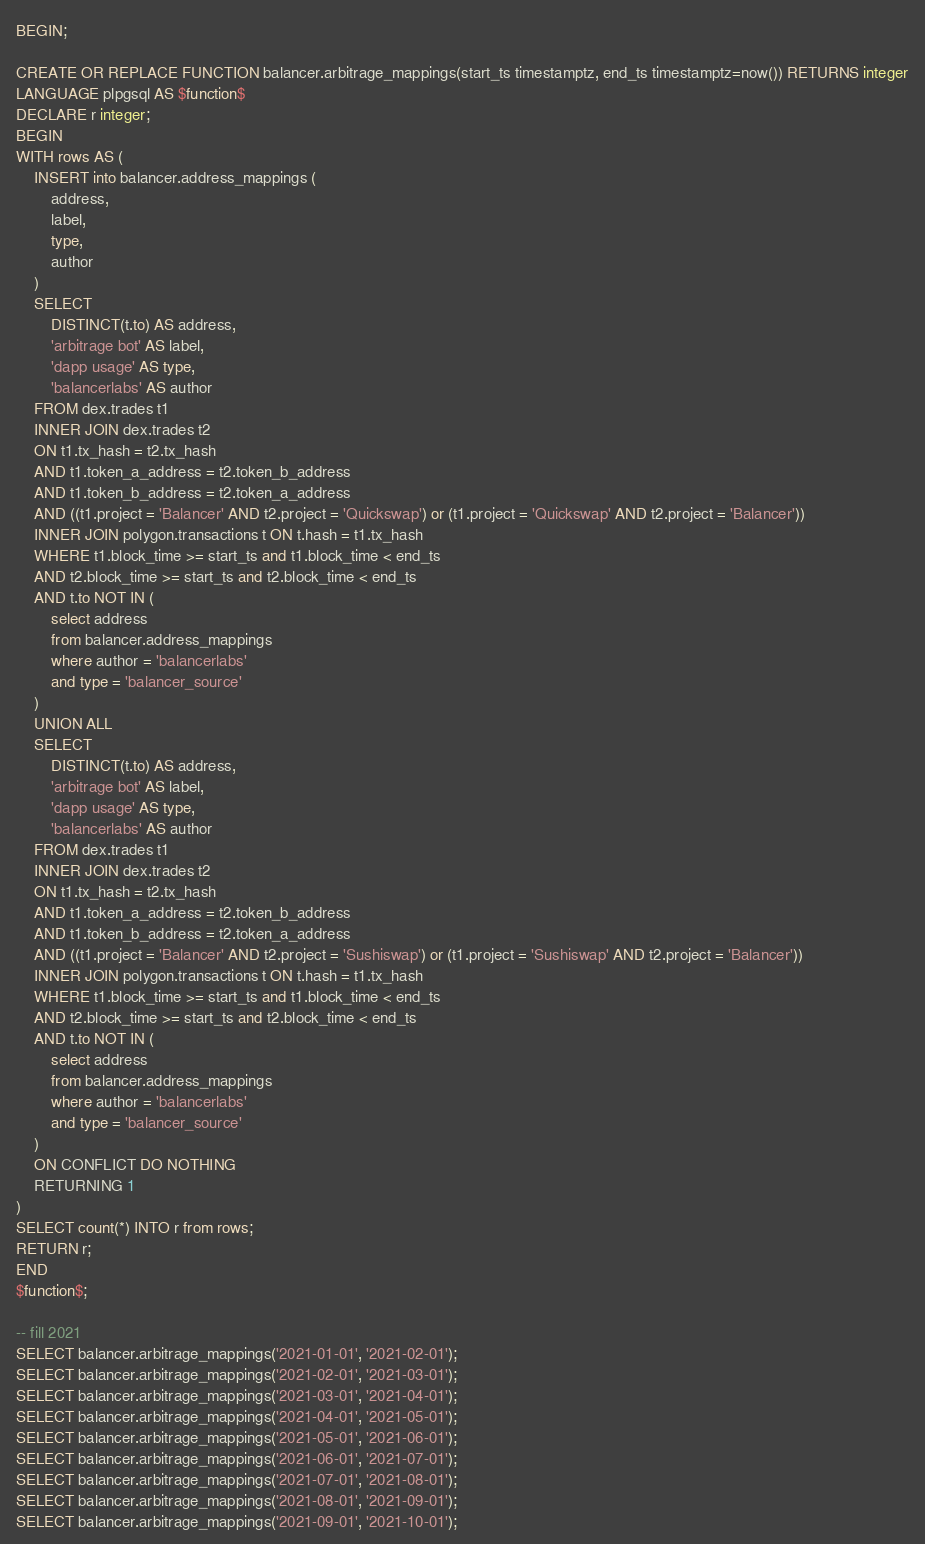<code> <loc_0><loc_0><loc_500><loc_500><_SQL_>BEGIN;

CREATE OR REPLACE FUNCTION balancer.arbitrage_mappings(start_ts timestamptz, end_ts timestamptz=now()) RETURNS integer
LANGUAGE plpgsql AS $function$
DECLARE r integer;
BEGIN
WITH rows AS (
    INSERT into balancer.address_mappings (
        address,
        label,
        type,
        author
    )
    SELECT
        DISTINCT(t.to) AS address,
        'arbitrage bot' AS label,
        'dapp usage' AS type,
        'balancerlabs' AS author
    FROM dex.trades t1
    INNER JOIN dex.trades t2
    ON t1.tx_hash = t2.tx_hash
    AND t1.token_a_address = t2.token_b_address
    AND t1.token_b_address = t2.token_a_address
    AND ((t1.project = 'Balancer' AND t2.project = 'Quickswap') or (t1.project = 'Quickswap' AND t2.project = 'Balancer'))
    INNER JOIN polygon.transactions t ON t.hash = t1.tx_hash
    WHERE t1.block_time >= start_ts and t1.block_time < end_ts
    AND t2.block_time >= start_ts and t2.block_time < end_ts
    AND t.to NOT IN (
        select address
        from balancer.address_mappings
        where author = 'balancerlabs'
        and type = 'balancer_source'
    )
    UNION ALL
    SELECT
        DISTINCT(t.to) AS address,
        'arbitrage bot' AS label,
        'dapp usage' AS type,
        'balancerlabs' AS author
    FROM dex.trades t1
    INNER JOIN dex.trades t2
    ON t1.tx_hash = t2.tx_hash
    AND t1.token_a_address = t2.token_b_address
    AND t1.token_b_address = t2.token_a_address
    AND ((t1.project = 'Balancer' AND t2.project = 'Sushiswap') or (t1.project = 'Sushiswap' AND t2.project = 'Balancer'))
    INNER JOIN polygon.transactions t ON t.hash = t1.tx_hash
    WHERE t1.block_time >= start_ts and t1.block_time < end_ts
    AND t2.block_time >= start_ts and t2.block_time < end_ts
    AND t.to NOT IN (
        select address
        from balancer.address_mappings
        where author = 'balancerlabs'
        and type = 'balancer_source'
    )
    ON CONFLICT DO NOTHING
    RETURNING 1
)
SELECT count(*) INTO r from rows;
RETURN r;
END
$function$;

-- fill 2021
SELECT balancer.arbitrage_mappings('2021-01-01', '2021-02-01');
SELECT balancer.arbitrage_mappings('2021-02-01', '2021-03-01');
SELECT balancer.arbitrage_mappings('2021-03-01', '2021-04-01');
SELECT balancer.arbitrage_mappings('2021-04-01', '2021-05-01');
SELECT balancer.arbitrage_mappings('2021-05-01', '2021-06-01');
SELECT balancer.arbitrage_mappings('2021-06-01', '2021-07-01');
SELECT balancer.arbitrage_mappings('2021-07-01', '2021-08-01');
SELECT balancer.arbitrage_mappings('2021-08-01', '2021-09-01');
SELECT balancer.arbitrage_mappings('2021-09-01', '2021-10-01');</code> 